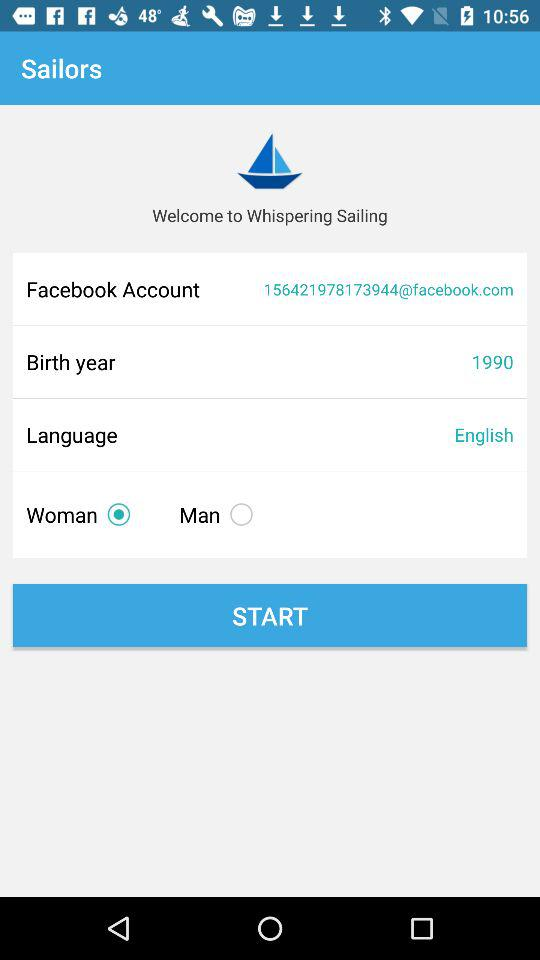What is the birth year? The birth year is 1990. 